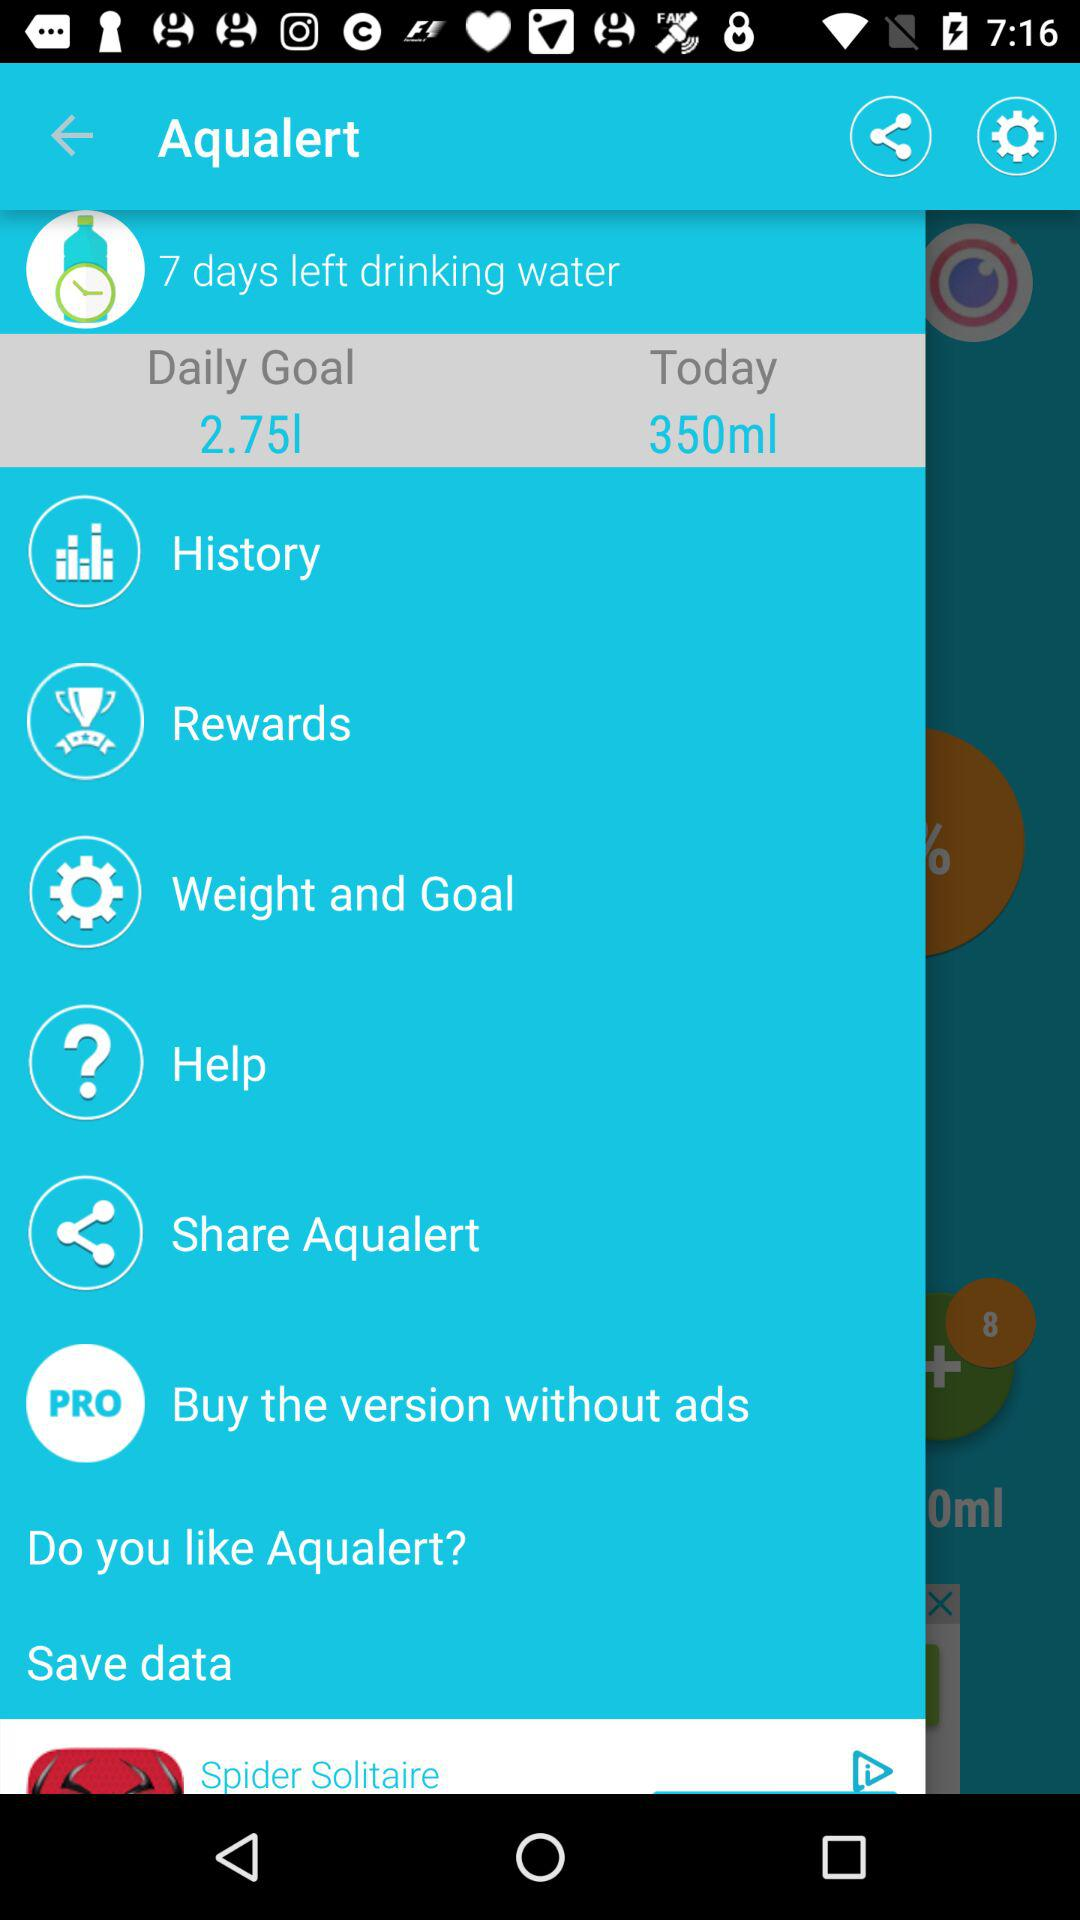What is the quantity of water in the daily goal? The quantity of water in the daily goal is 2.75 l. 